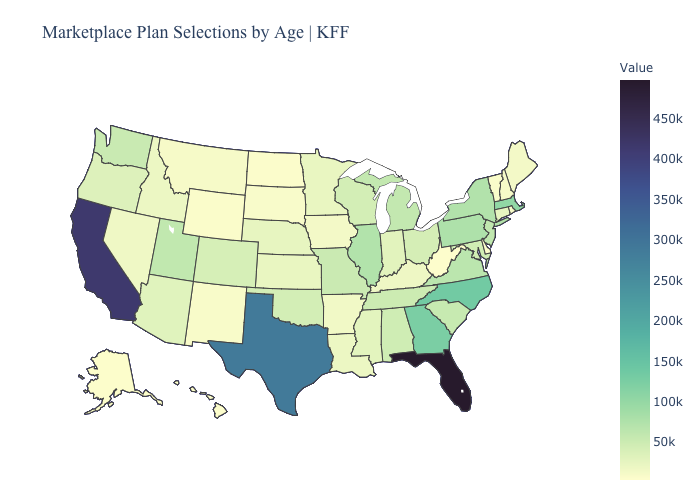Which states have the lowest value in the MidWest?
Keep it brief. North Dakota. Does New Mexico have the lowest value in the USA?
Write a very short answer. No. Does West Virginia have the lowest value in the USA?
Keep it brief. Yes. Which states hav the highest value in the West?
Keep it brief. California. Does Florida have the highest value in the USA?
Answer briefly. Yes. Does the map have missing data?
Quick response, please. No. 